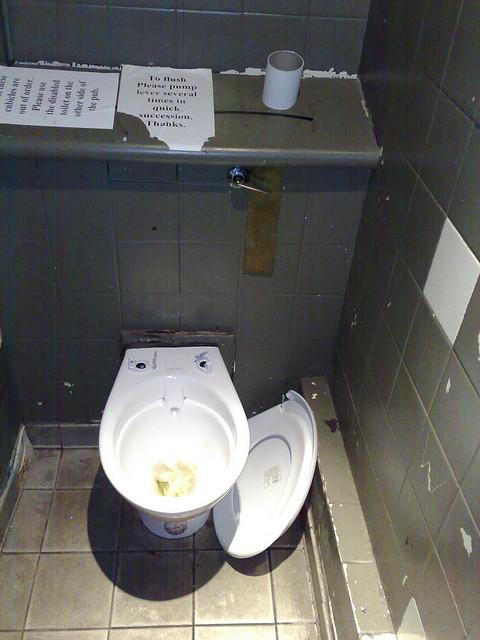What kind of room is this?
Give a very brief answer. Bathroom. Is the restroom clean?
Concise answer only. No. Why is the lid on the floor?
Short answer required. Broken. 